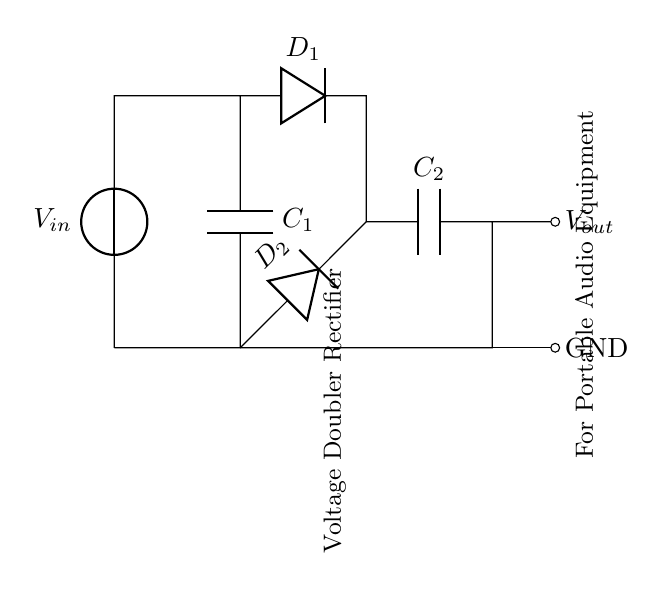What is the input voltage source labeled as? The input voltage source in the circuit is labeled as V in, representing the voltage supplied to the rectifier circuit.
Answer: V in How many capacitors are present in the circuit? There are two capacitors in the circuit, labeled as C1 and C2, which are part of the voltage doubler configuration.
Answer: 2 What type of rectifier is depicted in this circuit? The circuit is a voltage doubler rectifier, as indicated by the label within the diagram, meaning it is designed to double the input voltage using capacitors and diodes.
Answer: Voltage doubler What components are used to create the voltage doubling effect? The voltage doubling effect is achieved using two capacitors (C1 and C2) and two diodes (D1 and D2) in the rectification process outlined in the circuit.
Answer: Capacitors and diodes What is the output labeled as? The output of the circuit is labeled as V out, indicating the voltage produced after the rectification and voltage doubling process.
Answer: V out What is the function of D2 in the circuit? D2 allows current to flow in one direction, charging C2 during specific intervals of the AC cycle, thus helping to achieve the voltage doubling effect within the circuit.
Answer: Allow current flow What does the ground symbol represent in the circuit? The ground symbol indicates the reference point in the circuit, serving as the common return path for the electrical current, typically considered as zero voltage.
Answer: Ground 